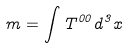Convert formula to latex. <formula><loc_0><loc_0><loc_500><loc_500>m = \int T ^ { 0 0 } d ^ { 3 } x</formula> 